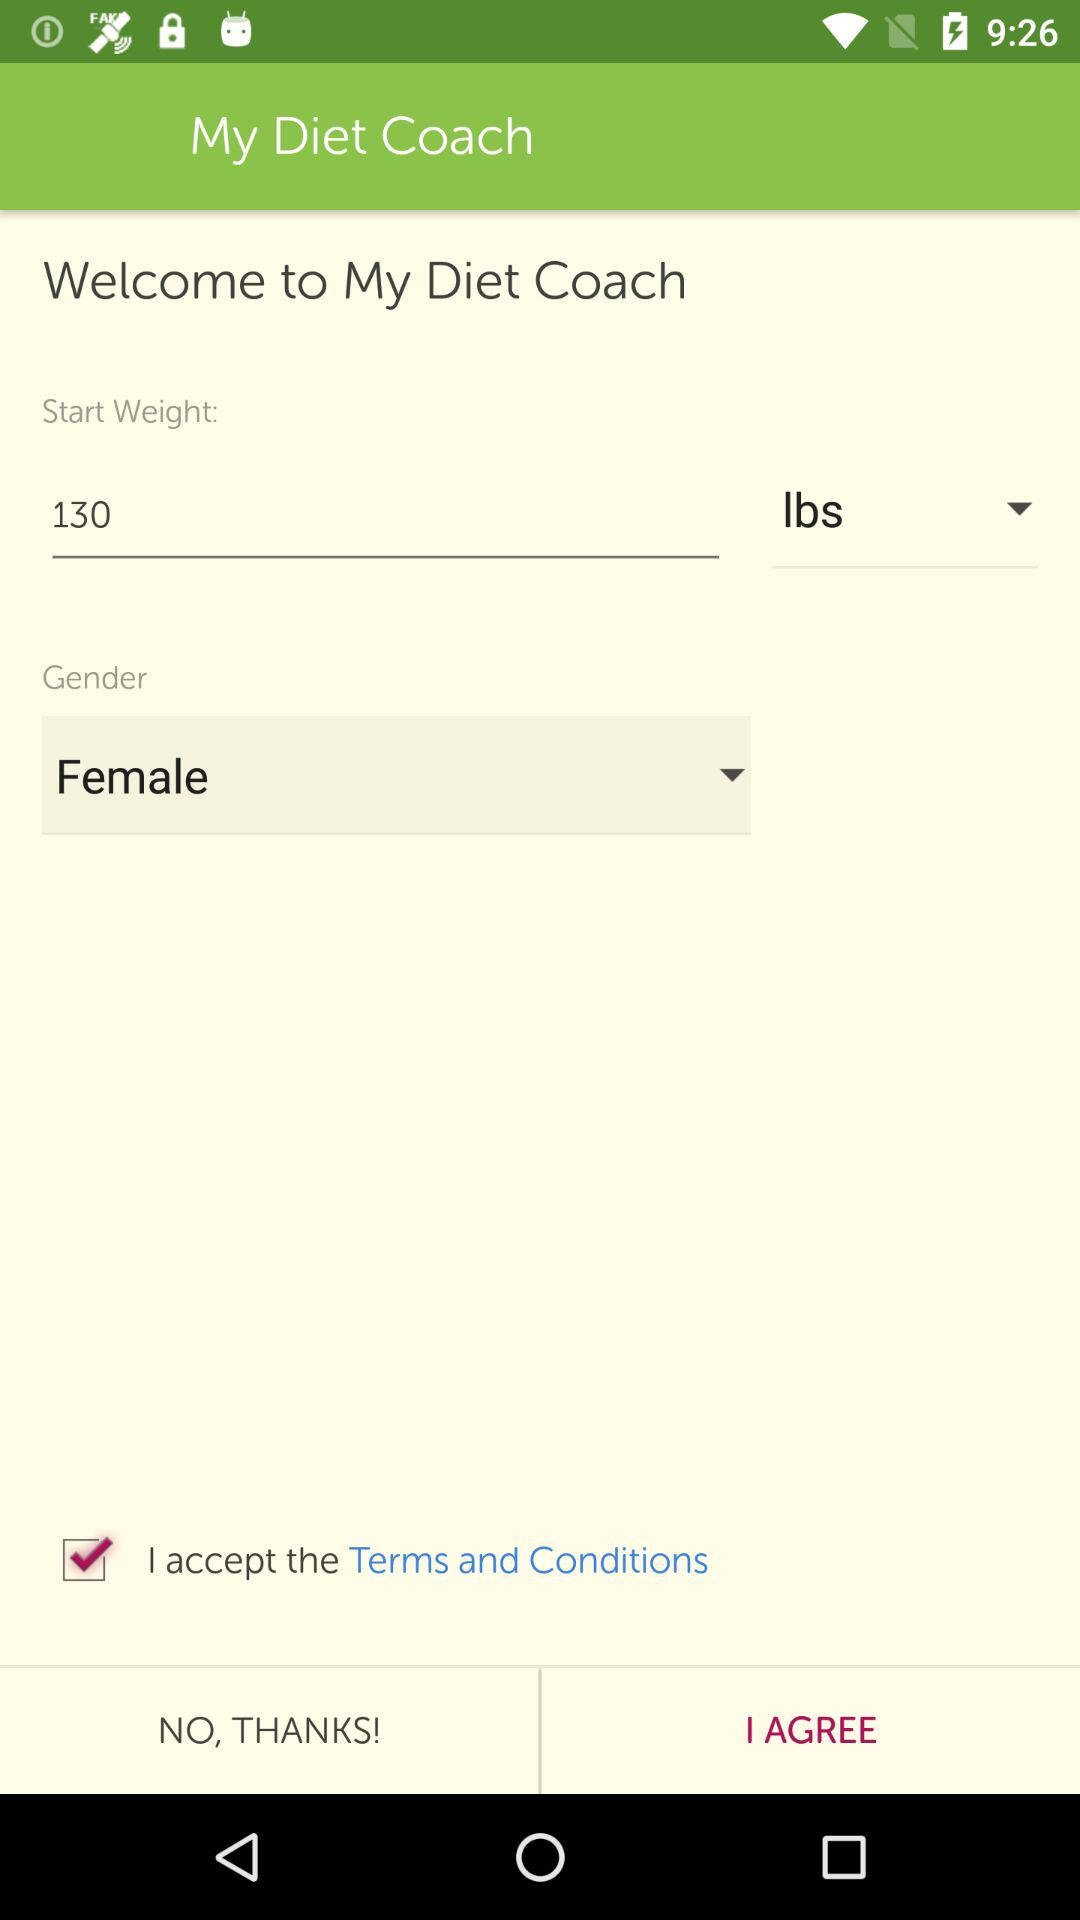What is the status of the option that includes acceptance to the “Terms and Conditions”? The status is "on". 